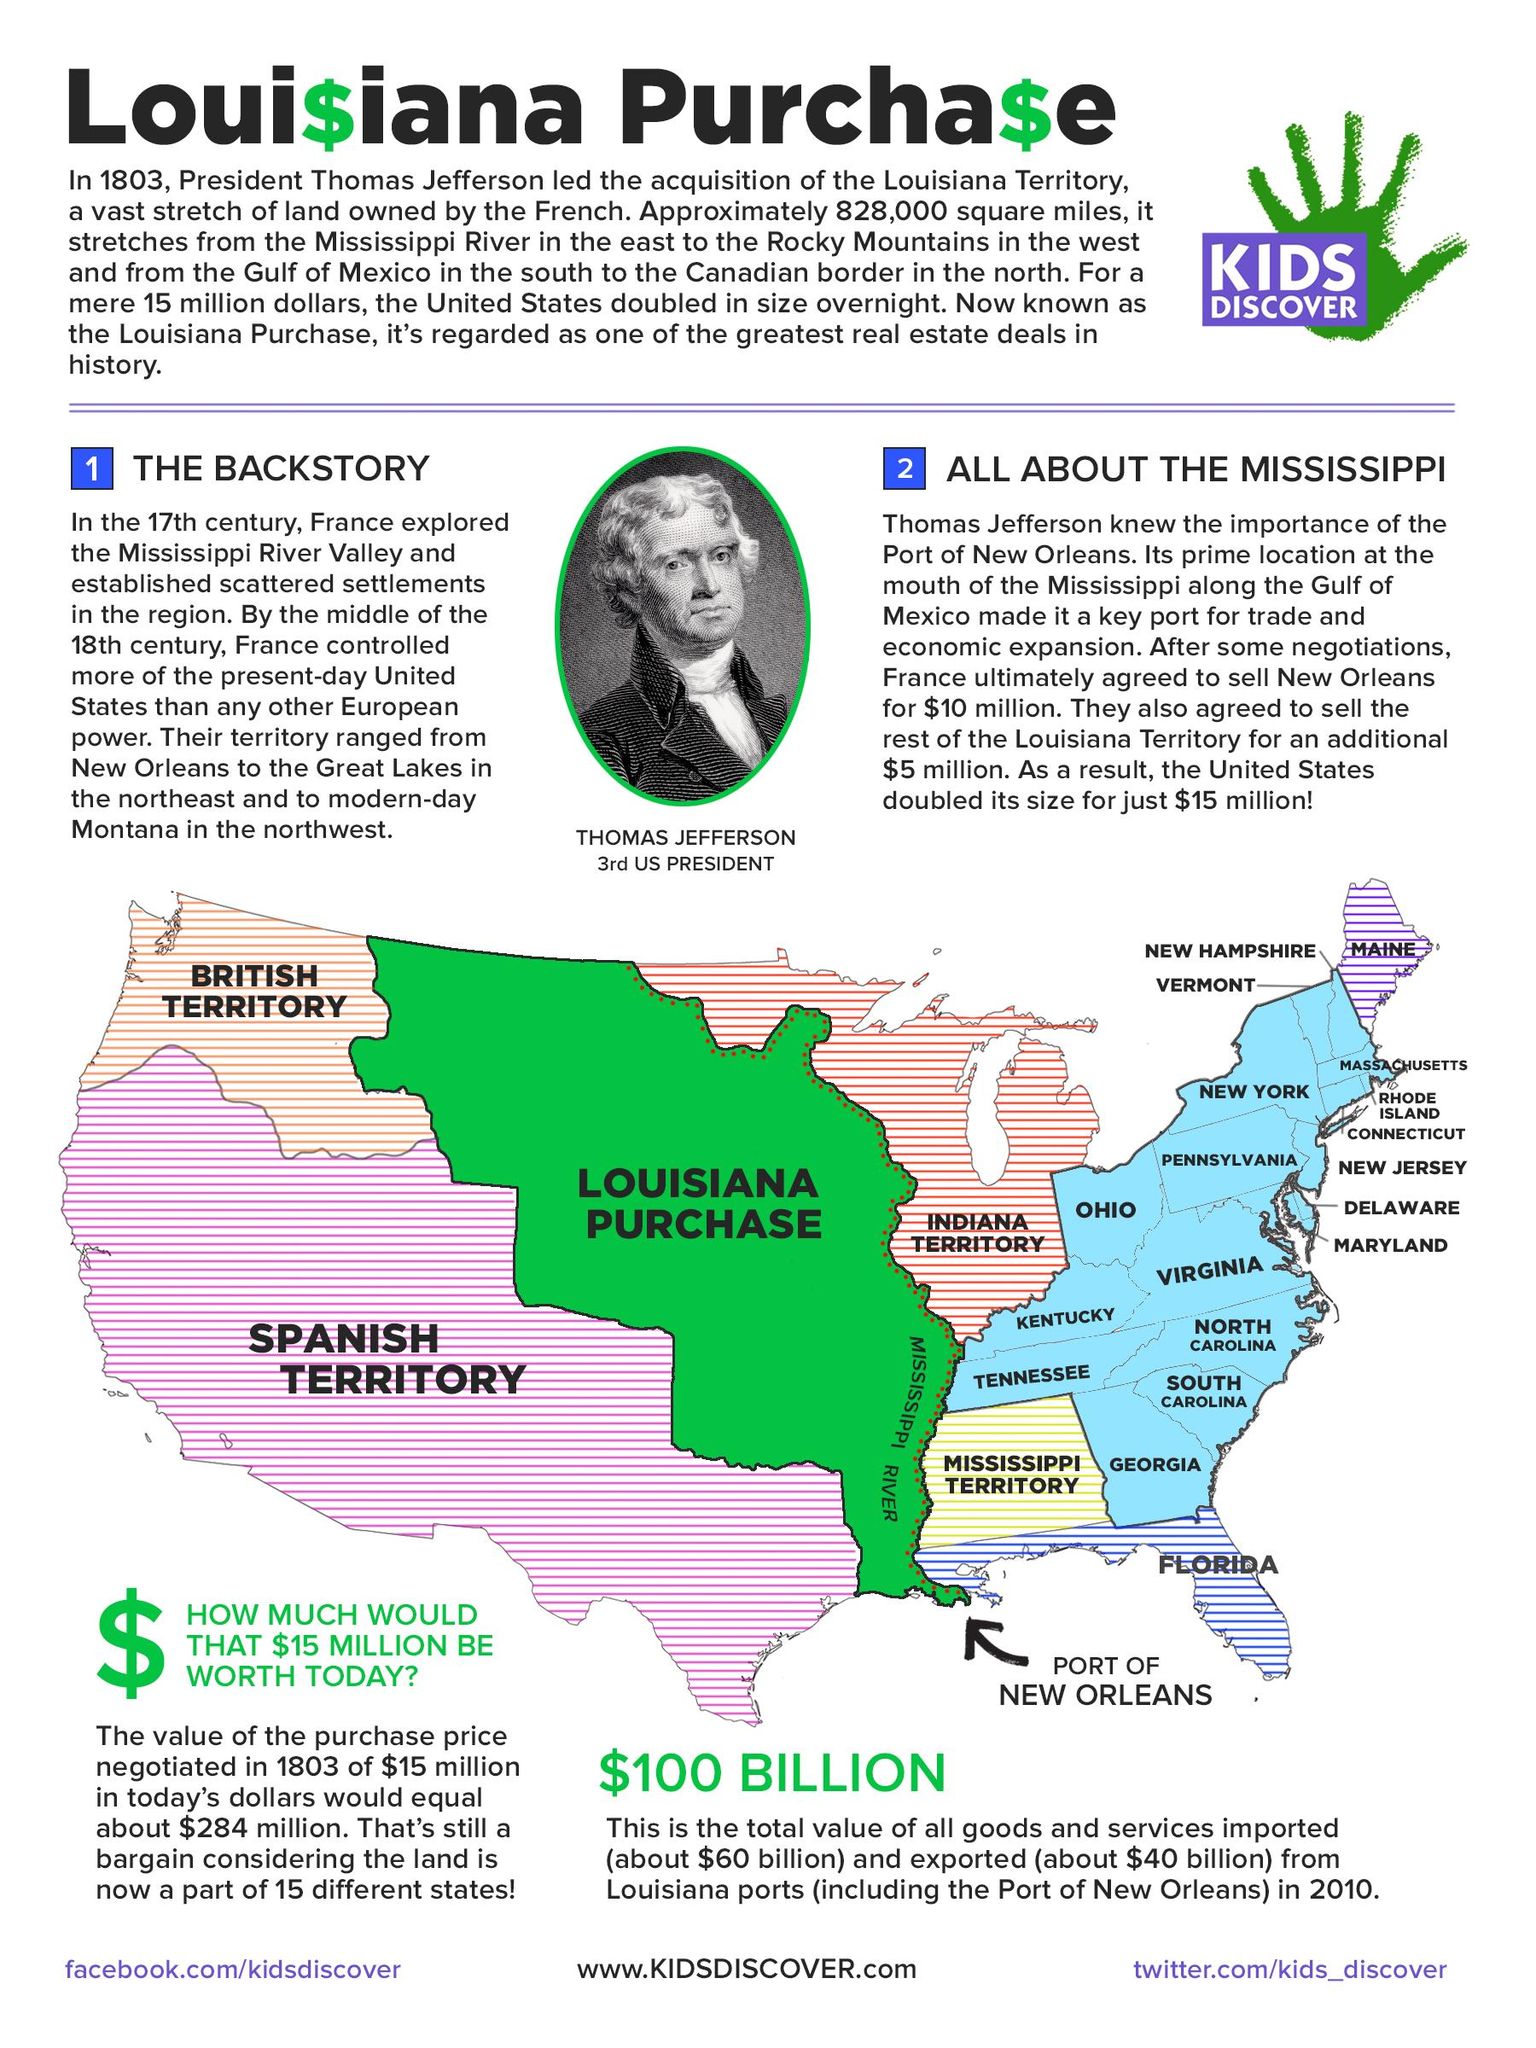Identify some key points in this picture. The Louisiana Purchase is considered one of the most significant real estate transactions in the history of the United States. In 2010, the total value of all goods and services imported and exported through Louisiana ports was approximately $100 billion. 